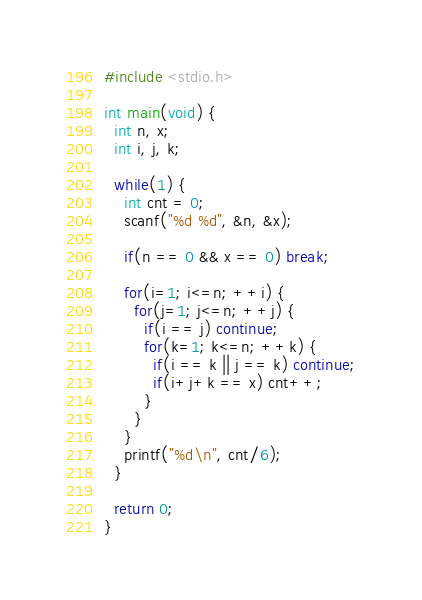Convert code to text. <code><loc_0><loc_0><loc_500><loc_500><_C_>#include <stdio.h>

int main(void) {
  int n, x;
  int i, j, k;

  while(1) {
    int cnt = 0;
    scanf("%d %d", &n, &x);

    if(n == 0 && x == 0) break;

    for(i=1; i<=n; ++i) {
      for(j=1; j<=n; ++j) {
        if(i == j) continue;
        for(k=1; k<=n; ++k) {
          if(i == k || j == k) continue;
          if(i+j+k == x) cnt++;
        }
      }
    }
    printf("%d\n", cnt/6);
  }

  return 0;
}

</code> 